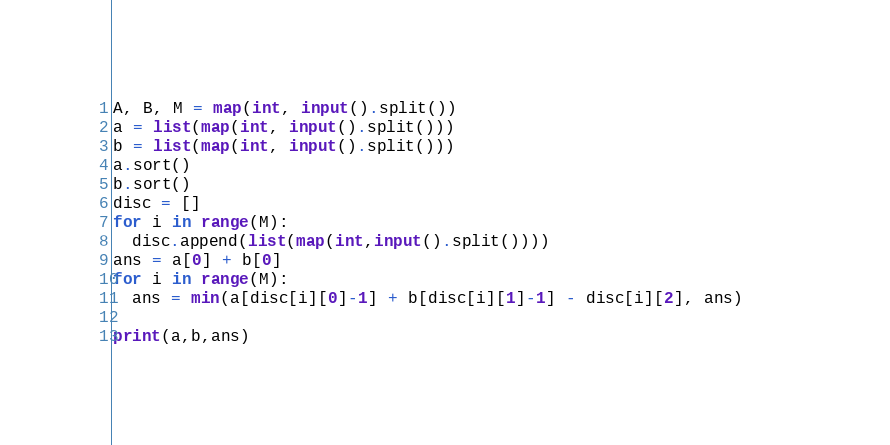<code> <loc_0><loc_0><loc_500><loc_500><_Python_>A, B, M = map(int, input().split())
a = list(map(int, input().split()))
b = list(map(int, input().split()))
a.sort()
b.sort()
disc = []
for i in range(M):
  disc.append(list(map(int,input().split())))
ans = a[0] + b[0]
for i in range(M):
  ans = min(a[disc[i][0]-1] + b[disc[i][1]-1] - disc[i][2], ans)     
    
print(a,b,ans)</code> 